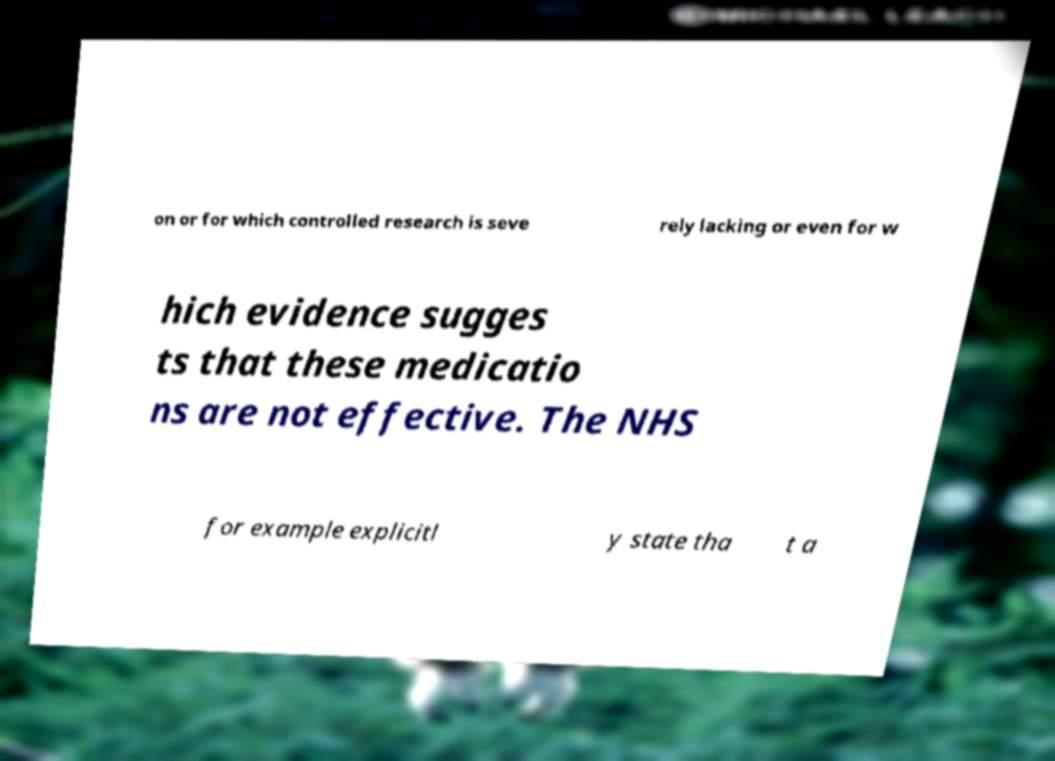Please identify and transcribe the text found in this image. on or for which controlled research is seve rely lacking or even for w hich evidence sugges ts that these medicatio ns are not effective. The NHS for example explicitl y state tha t a 